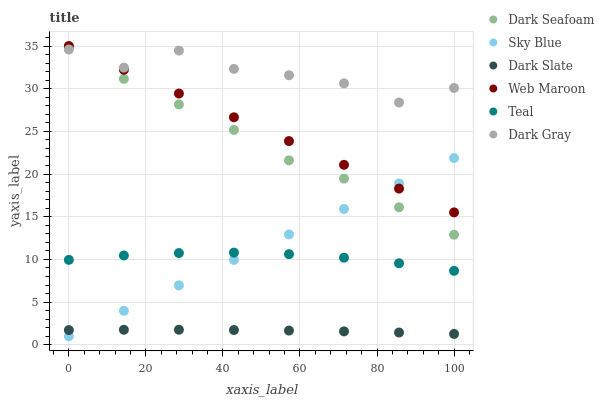Does Dark Slate have the minimum area under the curve?
Answer yes or no. Yes. Does Dark Gray have the maximum area under the curve?
Answer yes or no. Yes. Does Dark Gray have the minimum area under the curve?
Answer yes or no. No. Does Dark Slate have the maximum area under the curve?
Answer yes or no. No. Is Sky Blue the smoothest?
Answer yes or no. Yes. Is Dark Gray the roughest?
Answer yes or no. Yes. Is Dark Slate the smoothest?
Answer yes or no. No. Is Dark Slate the roughest?
Answer yes or no. No. Does Sky Blue have the lowest value?
Answer yes or no. Yes. Does Dark Slate have the lowest value?
Answer yes or no. No. Does Web Maroon have the highest value?
Answer yes or no. Yes. Does Dark Gray have the highest value?
Answer yes or no. No. Is Dark Slate less than Teal?
Answer yes or no. Yes. Is Web Maroon greater than Teal?
Answer yes or no. Yes. Does Teal intersect Sky Blue?
Answer yes or no. Yes. Is Teal less than Sky Blue?
Answer yes or no. No. Is Teal greater than Sky Blue?
Answer yes or no. No. Does Dark Slate intersect Teal?
Answer yes or no. No. 